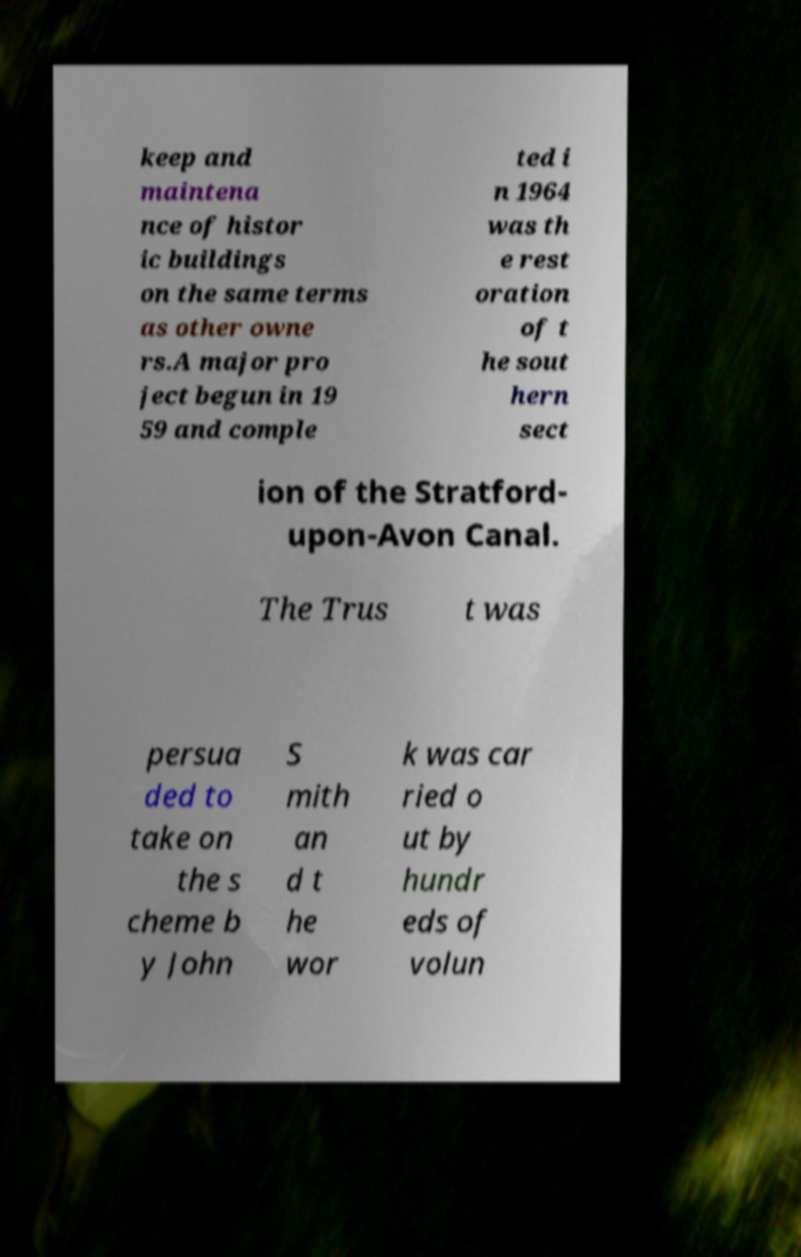Could you assist in decoding the text presented in this image and type it out clearly? keep and maintena nce of histor ic buildings on the same terms as other owne rs.A major pro ject begun in 19 59 and comple ted i n 1964 was th e rest oration of t he sout hern sect ion of the Stratford- upon-Avon Canal. The Trus t was persua ded to take on the s cheme b y John S mith an d t he wor k was car ried o ut by hundr eds of volun 